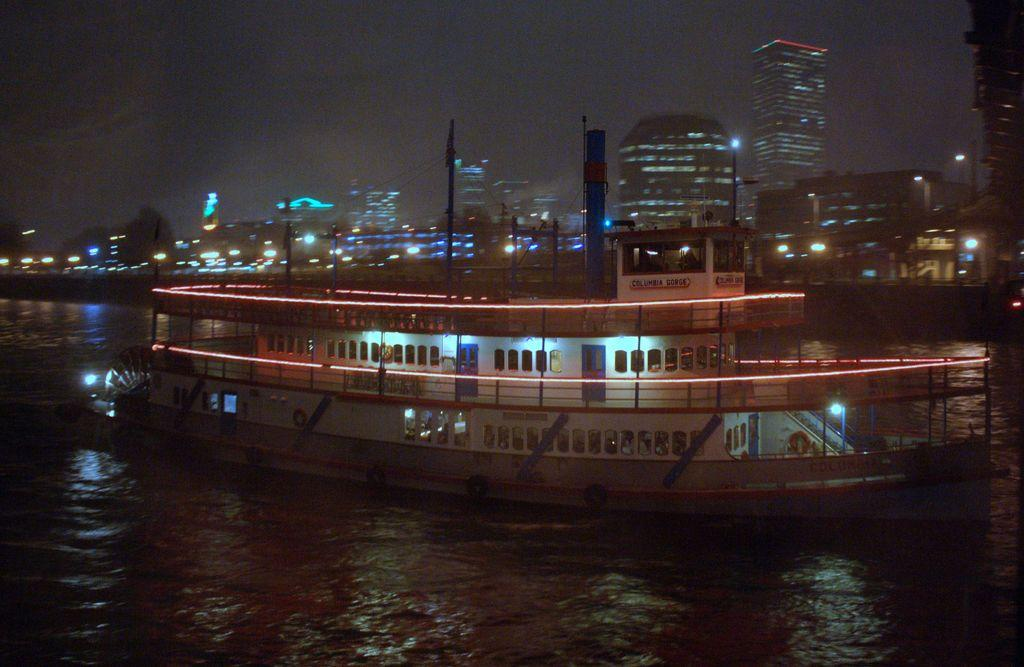What is the main subject of the image? The main subject of the image is a ship on the water. What type of lighting is visible in the image? Electric lights and street lights are present in the image. What structures can be seen in the image? Poles, towers, buildings, a bridge, and a skyscraper are visible in the image. What natural elements are present in the image? Trees are visible in the image. What part of the natural environment is visible in the image? The sky is visible in the image. Can you recall the memory of the ship's captain talking about the questions he had about the sky? There is no conversation or memory present in the image, as it is a static representation of a ship on the water and its surroundings. 